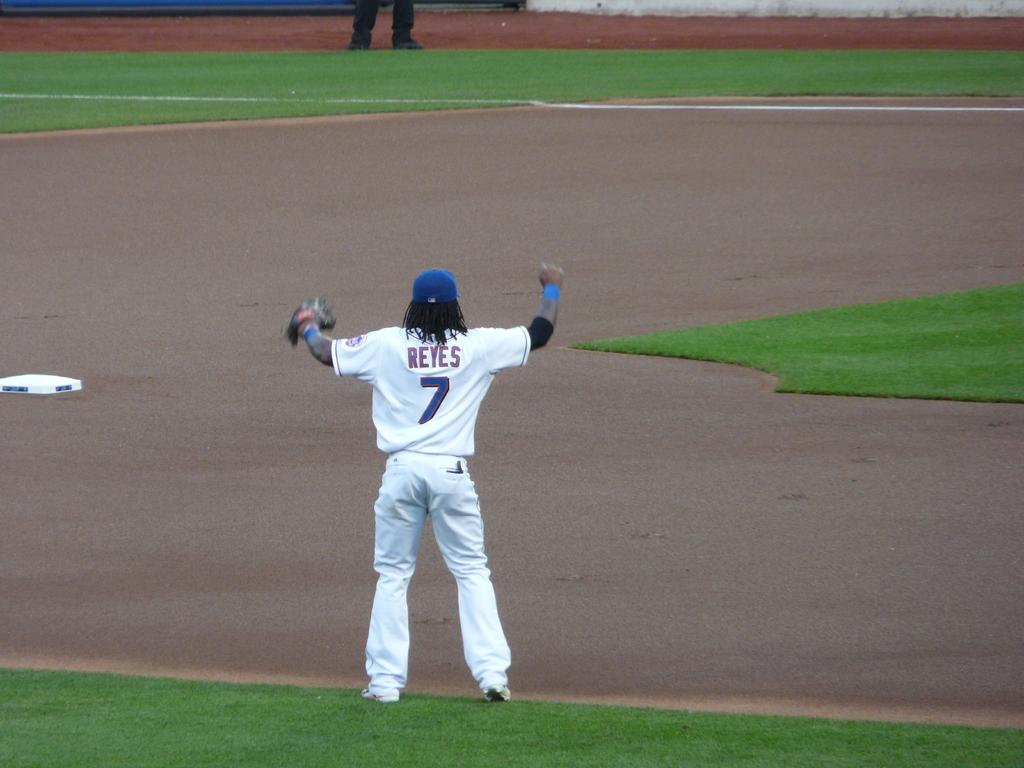<image>
Render a clear and concise summary of the photo. Reyes stands alone on the pitch with his arms up. 